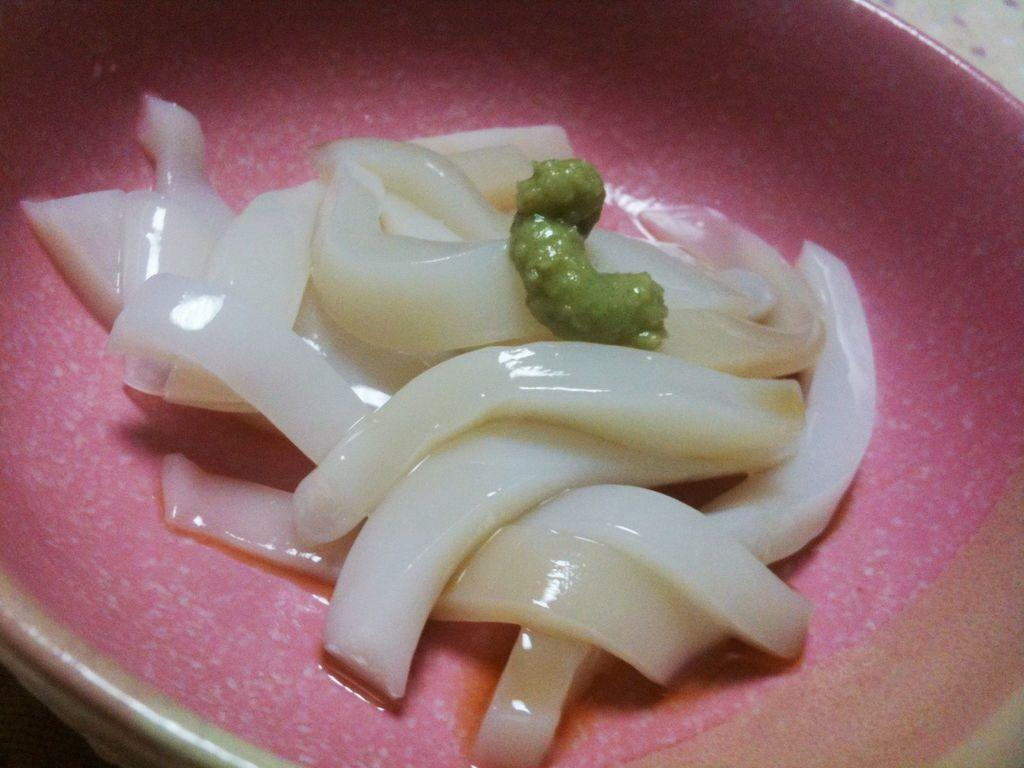What is inside the container that can be seen in the image? There is a container with food items in the image. Can you describe the object located in the top right corner of the image? Unfortunately, the provided facts do not give enough information to describe the object in the top right corner of the image. How many sheep are visible in the image? There are no sheep present in the image. What type of pickle is being used as a decoration in the image? There is no mention of pickles or any decorative elements in the image. 